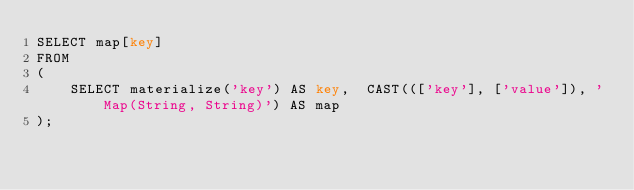Convert code to text. <code><loc_0><loc_0><loc_500><loc_500><_SQL_>SELECT map[key]
FROM
(
    SELECT materialize('key') AS key,  CAST((['key'], ['value']), 'Map(String, String)') AS map
);
</code> 